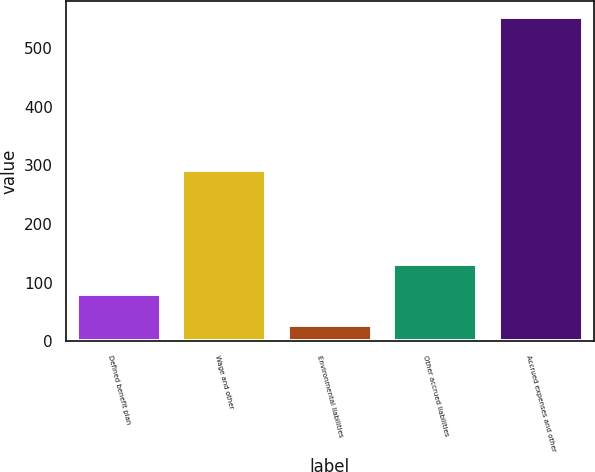Convert chart. <chart><loc_0><loc_0><loc_500><loc_500><bar_chart><fcel>Defined benefit plan<fcel>Wage and other<fcel>Environmental liabilities<fcel>Other accrued liabilities<fcel>Accrued expenses and other<nl><fcel>79.7<fcel>292<fcel>27<fcel>132.4<fcel>554<nl></chart> 